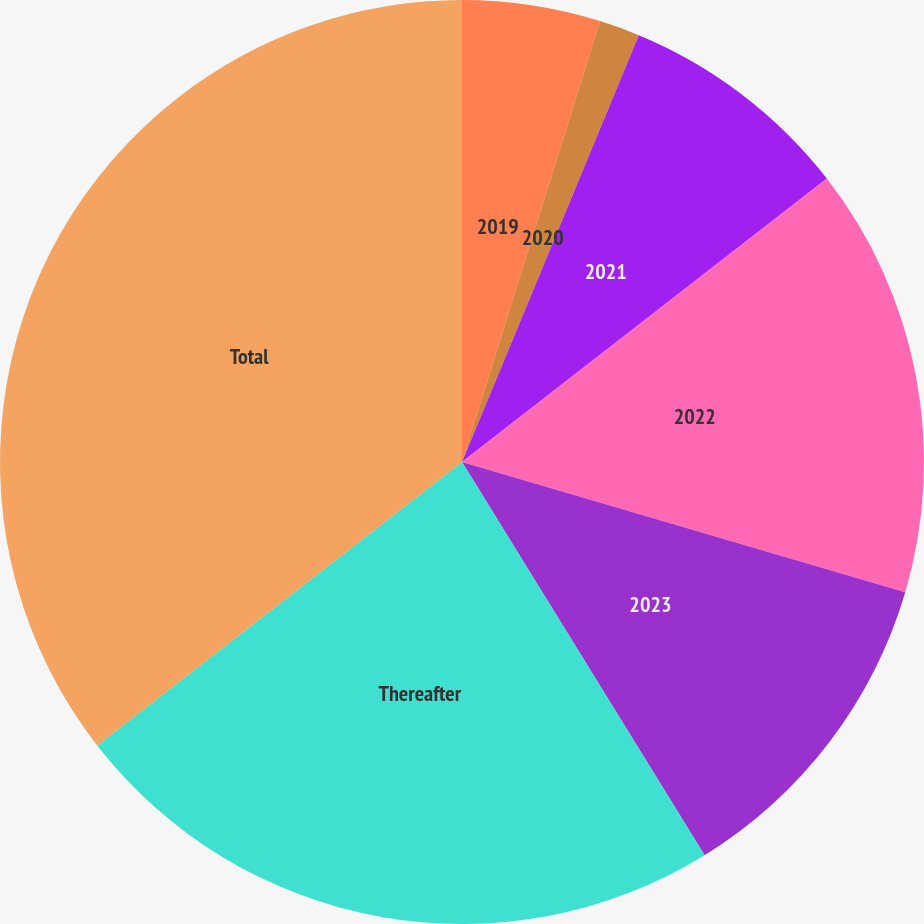Convert chart to OTSL. <chart><loc_0><loc_0><loc_500><loc_500><pie_chart><fcel>2019<fcel>2020<fcel>2021<fcel>2022<fcel>2023<fcel>Thereafter<fcel>Total<nl><fcel>4.83%<fcel>1.42%<fcel>8.24%<fcel>15.06%<fcel>11.65%<fcel>23.29%<fcel>35.51%<nl></chart> 